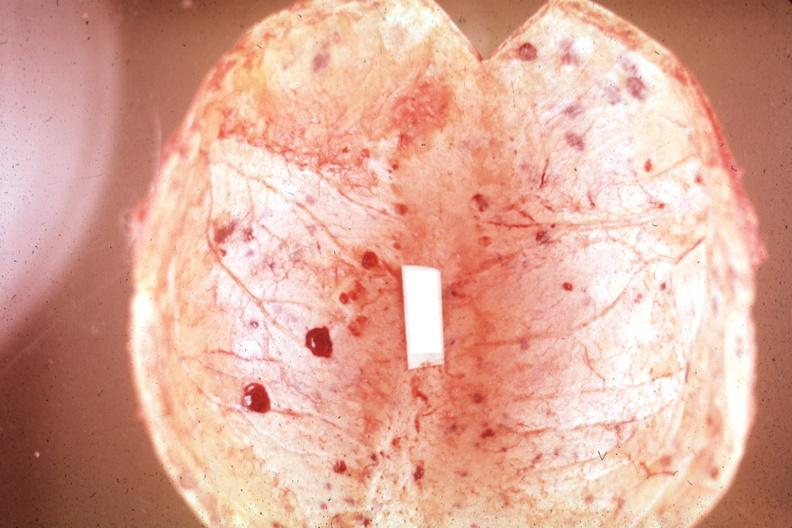does oil acid show not the best color in photo?
Answer the question using a single word or phrase. No 